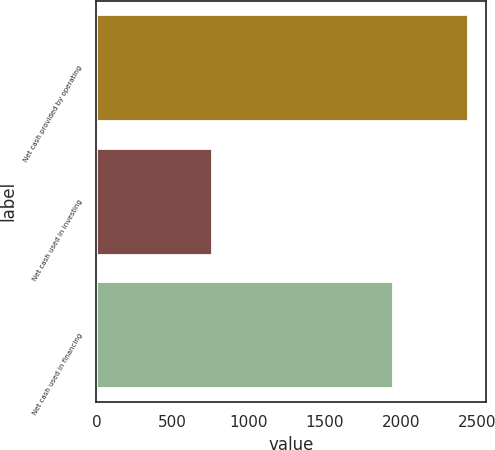<chart> <loc_0><loc_0><loc_500><loc_500><bar_chart><fcel>Net cash provided by operating<fcel>Net cash used in investing<fcel>Net cash used in financing<nl><fcel>2439<fcel>761<fcel>1946<nl></chart> 